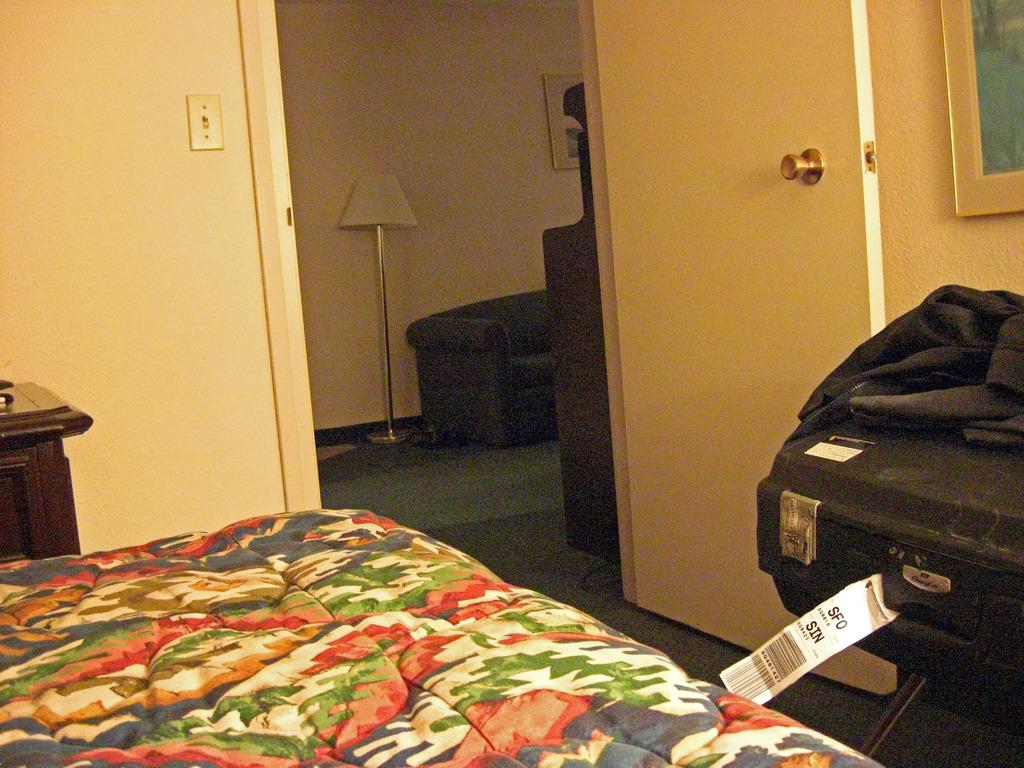What type of furniture is present in the image? There is a bed and a table in the image. What other objects can be seen in the image? There is a suitcase, a cloth door, a window, a lamp, a photo frame on the wall, and a card with some text in the image. What type of underwear is hanging on the cloth door in the image? There is no underwear present in the image; it features a cloth door, but no clothing items are visible. Can you tell me what the mother is doing in the image? There is no mother or any person present in the image, so it is not possible to answer that question. 